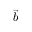Convert formula to latex. <formula><loc_0><loc_0><loc_500><loc_500>\vec { b }</formula> 